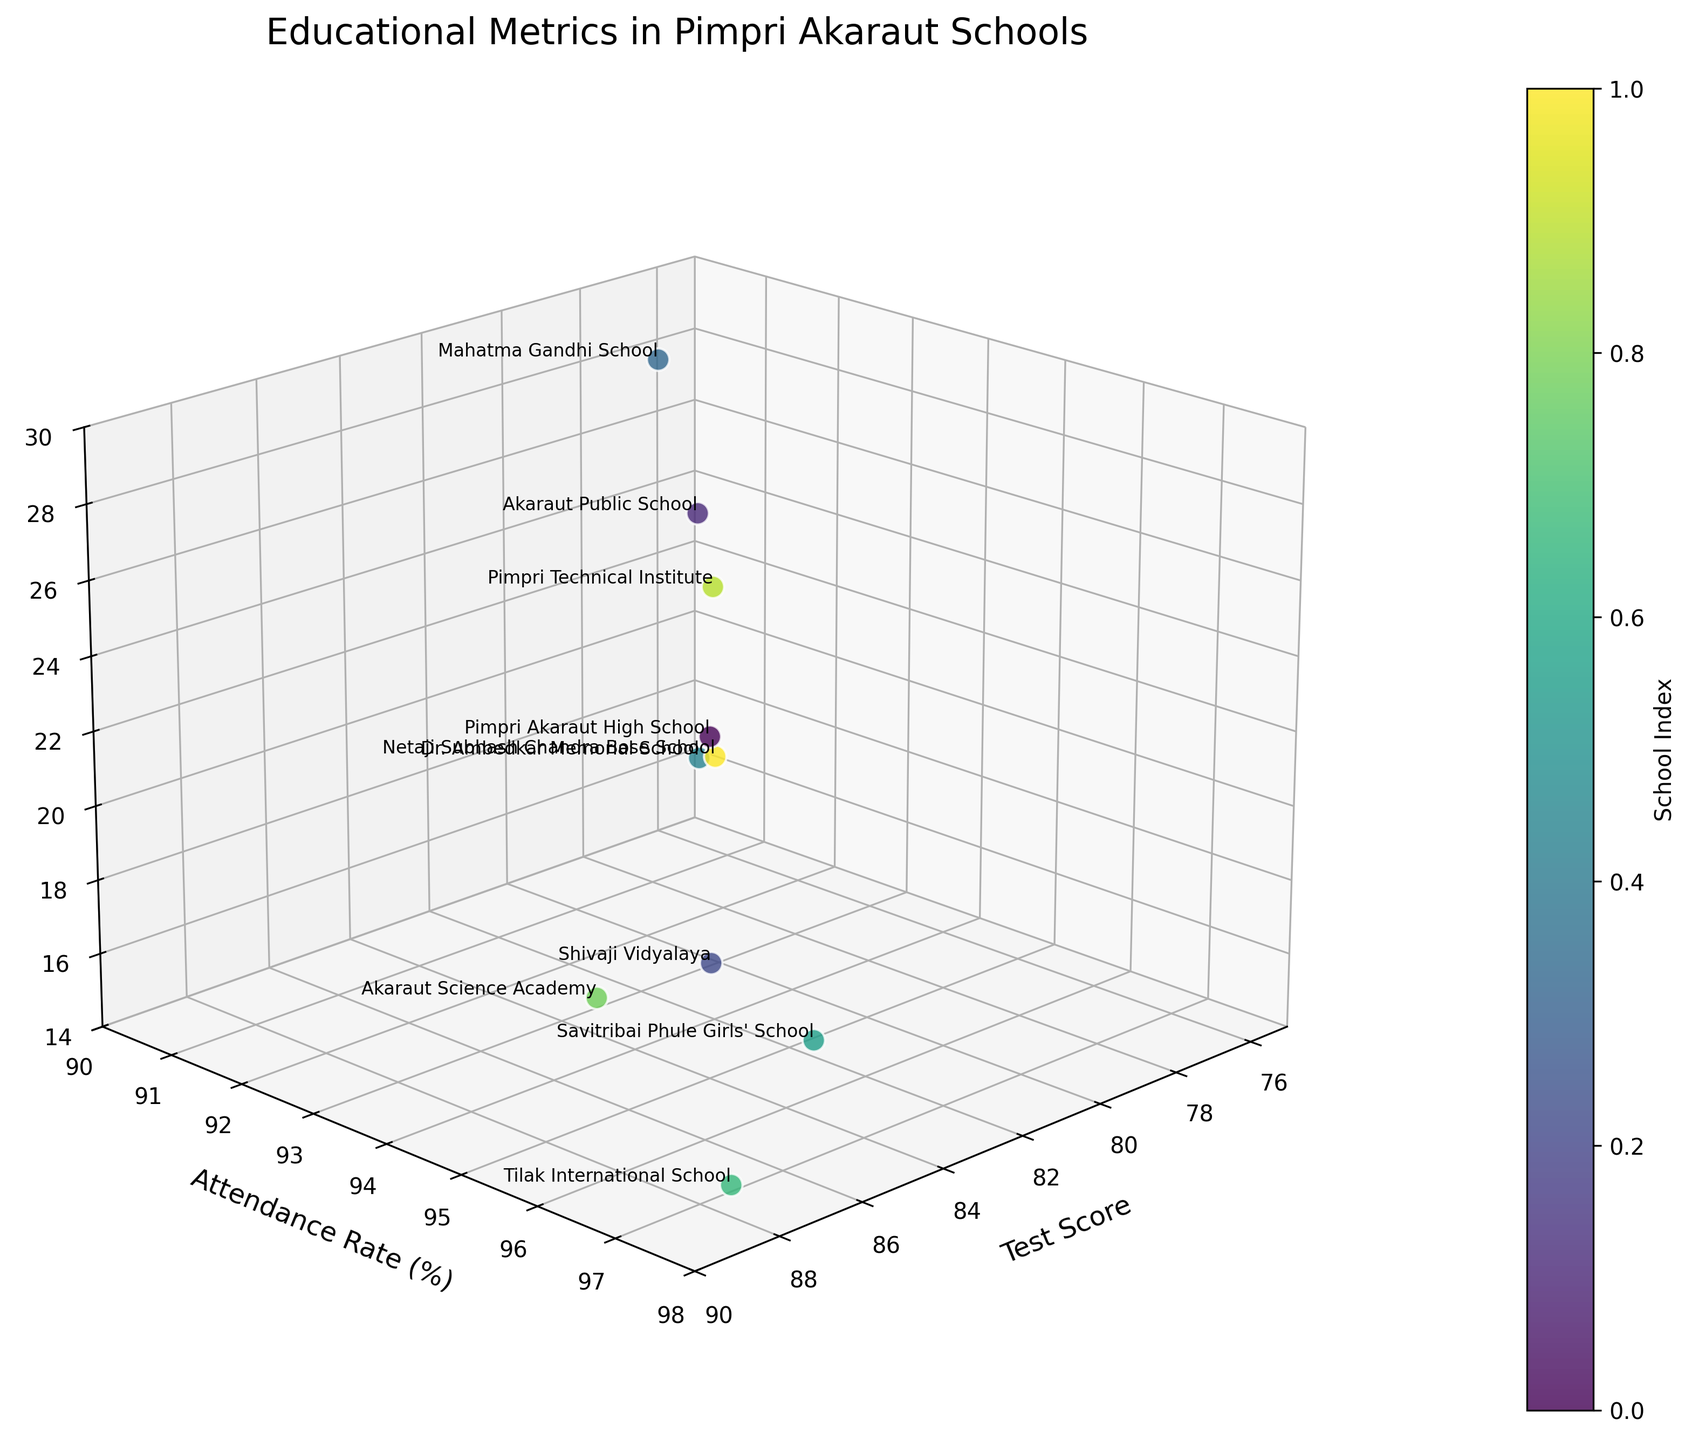What's the title of the figure? The title of the figure is typically located at the top of the plot. In this case, the title is given in the code as 'Educational Metrics in Pimpri Akaraut Schools'.
Answer: Educational Metrics in Pimpri Akaraut Schools How many data points are shown in the figure? Each school represents one data point. There are 10 schools listed in the provided data, so there will be 10 data points shown on the plot.
Answer: 10 Which school has the highest test score? By looking at the highest value on the Test Score axis and identifying the label for that point, we see that Tilak International School has the highest test score of 88.2.
Answer: Tilak International School What is the teacher-student ratio for Savitribai Phule Girls' School? By finding Savitribai Phule Girls' School in the plot and reading the value on the z-axis, we see the teacher-student ratio is 1:16, which in numerical format is 16 students per teacher.
Answer: 1:16 Which school has the highest attendance rate and what is that rate? By locating the highest point on the Attendance Rate axis and identifying the associated label, we find that Tilak International School has the highest attendance rate of 97.5%.
Answer: 97.5% What is the average test score of all the schools? The test scores are: 82.5, 78.3, 85.1, 76.9, 80.7, 83.9, 88.2, 86.4, 79.6, 81.8. Adding these up equals 823.4. Dividing by 10 (number of schools) gives an average score of 82.34.
Answer: 82.34 Which school has the lowest teacher-student ratio and how does it compare to the school with the highest ratio? By comparing points on the z-axis, we find that Tilak International School has the lowest ratio (15), while Mahatma Gandhi School has the highest ratio (28). The difference between them is 28 - 15 = 13.
Answer: Tilak International School has 13 fewer students per teacher compared to Mahatma Gandhi School Is there a clear relationship between test scores and attendance rates? By visually examining the scatter plot, we see that points with high test scores generally are associated with high attendance rates. This suggests a positive correlation between test scores and attendance rates.
Answer: Yes, there appears to be a positive correlation Which school has the second lowest attendance rate and what is that rate? By identifying and comparing the points on the Attendance Rate axis, Mahatma Gandhi School has the lowest, and Akaraut Public School has the second lowest at 91.8%.
Answer: 91.8% Are the schools with lower teacher-student ratios achieving higher test scores? Observing the plot for lower values on the z-axis (fewer students per teacher) and checking their corresponding test scores, we notice schools like Tilak International School and Savitribai Phule Girls' School, which have low student-teacher ratios, also have high test scores.
Answer: Yes, generally higher test scores are seen with lower teacher-student ratios 